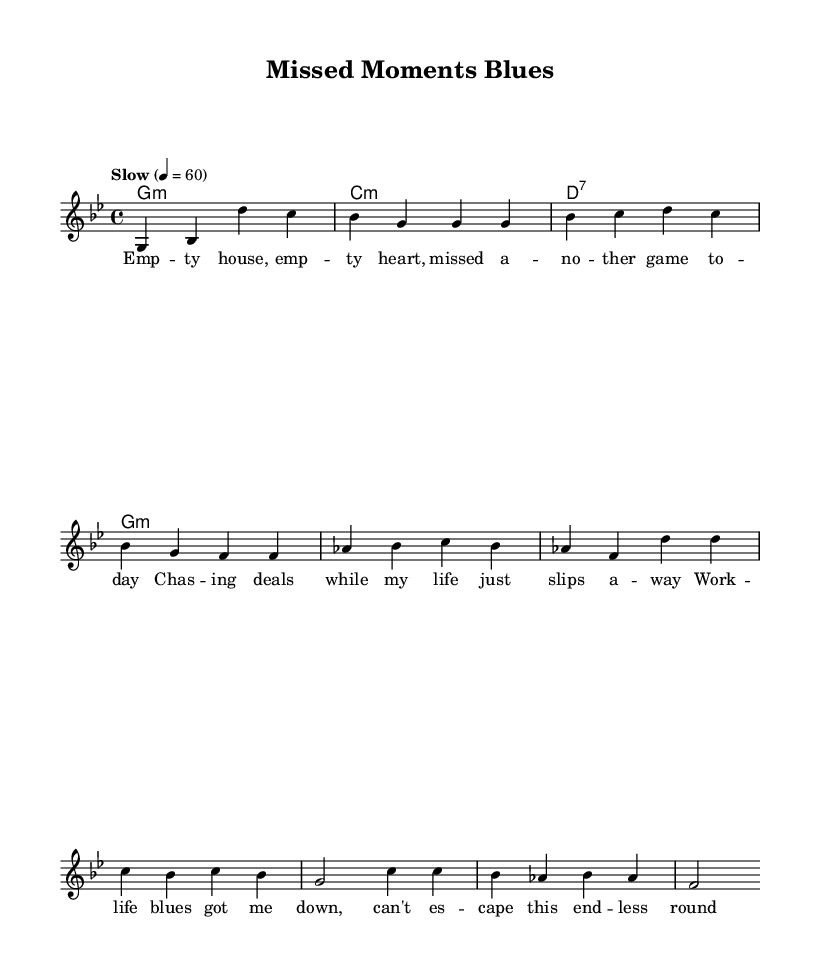What is the key signature of this music? The key signature is G minor, which has two flats. This can be identified by the key signature shown at the beginning of the staff marked with two flat symbols.
Answer: G minor What is the time signature of this music? The time signature is 4/4, indicated at the beginning of the score. This means there are four beats in each measure and the quarter note gets one beat.
Answer: 4/4 What is the tempo marking of this music? The tempo is marked as "Slow" with a metronome marking of 60, which indicates a slow pace of 60 beats per minute. This information is located in the tempo section right above the staff.
Answer: Slow How many measures are in the melody? The melody consists of eight measures in total. The measures can be counted from the beginning of the melody section up to the end of the chorus.
Answer: Eight What is the primary emotion conveyed in the lyrics? The primary emotion in the lyrics is melancholic, reflecting on feelings of regret and sadness regarding missed family moments and the struggles with work-life balance. This is inferred from the themes in the lyrics of missing family time and feeling down.
Answer: Melancholic How does the harmony support the melody in the chorus? The harmony in the chorus uses chord progressions that mirror the emotional gravity of the melody, with transitions from D7 to G minor emphasizing the feeling of being down and the cyclical nature of the work-life blues. The relationship can be observed by looking at how the chords are aligned with the melodic phrases.
Answer: Reflects the mood 